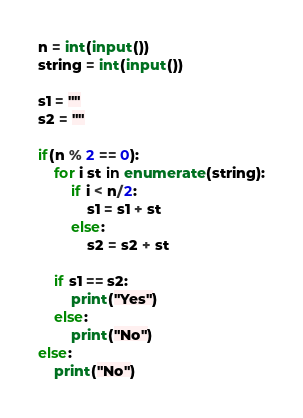Convert code to text. <code><loc_0><loc_0><loc_500><loc_500><_Python_>n = int(input())
string = int(input())

s1 = ""
s2 = ""

if(n % 2 == 0):
    for i st in enumerate(string):
        if i < n/2:
            s1 = s1 + st
        else:
            s2 = s2 + st

    if s1 == s2:
        print("Yes")
    else:
        print("No")
else:
    print("No")
</code> 